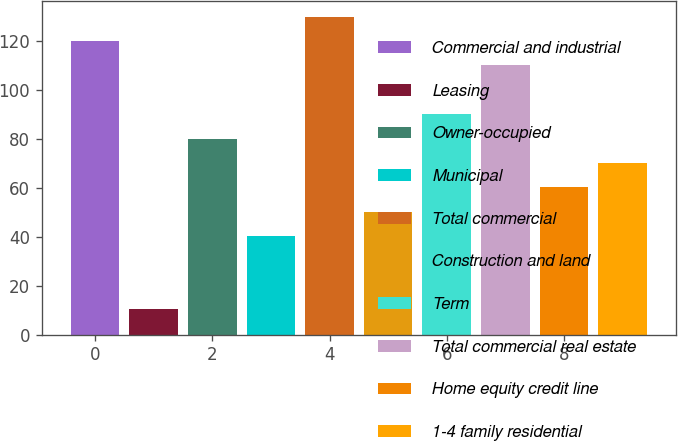Convert chart. <chart><loc_0><loc_0><loc_500><loc_500><bar_chart><fcel>Commercial and industrial<fcel>Leasing<fcel>Owner-occupied<fcel>Municipal<fcel>Total commercial<fcel>Construction and land<fcel>Term<fcel>Total commercial real estate<fcel>Home equity credit line<fcel>1-4 family residential<nl><fcel>119.9<fcel>10.45<fcel>80.1<fcel>40.3<fcel>129.85<fcel>50.25<fcel>90.05<fcel>109.95<fcel>60.2<fcel>70.15<nl></chart> 